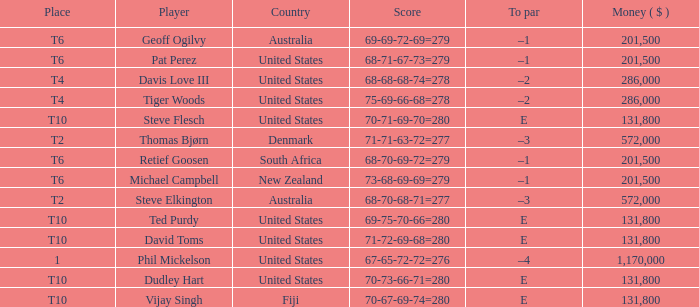What is the largest money for a t4 place, for Tiger Woods? 286000.0. 